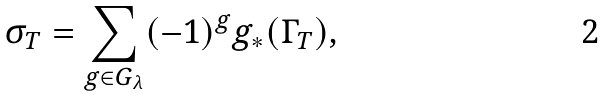<formula> <loc_0><loc_0><loc_500><loc_500>\sigma _ { T } = \sum _ { g \in G _ { \lambda } } ( - 1 ) ^ { g } g _ { * } ( \Gamma _ { T } ) ,</formula> 